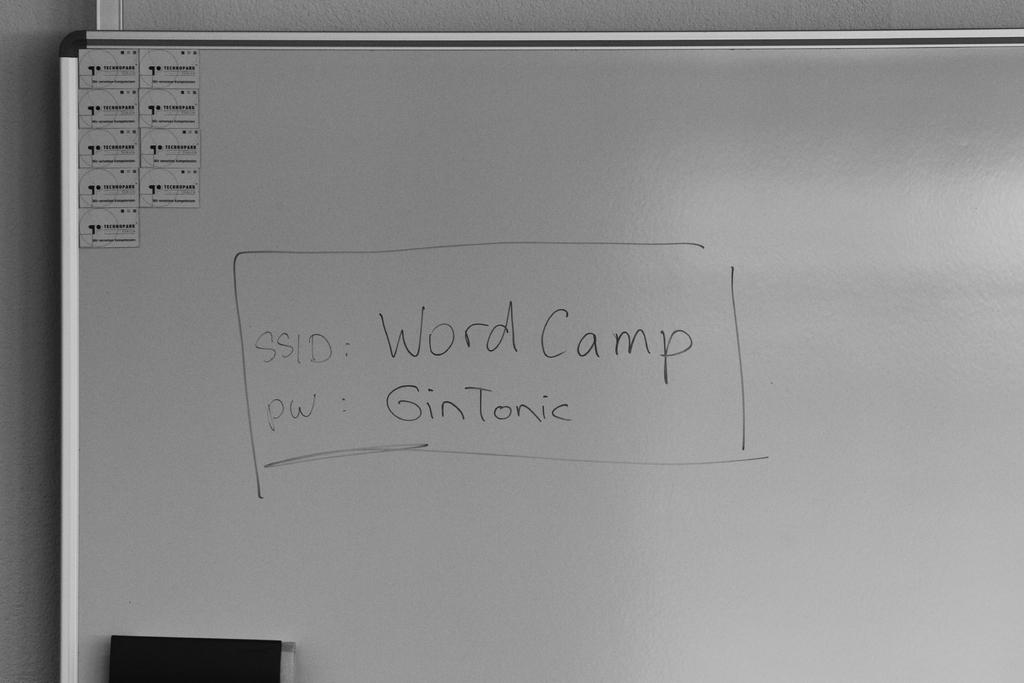<image>
Share a concise interpretation of the image provided. The password written on the board is "GinTonic". 